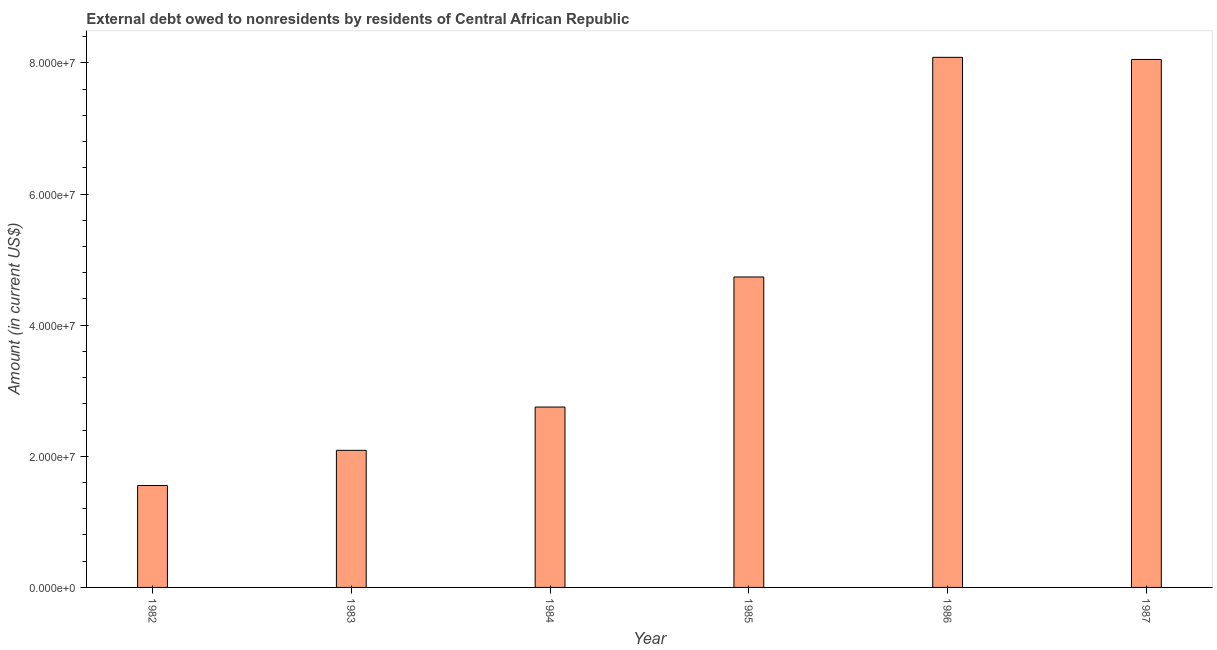Does the graph contain any zero values?
Keep it short and to the point. No. Does the graph contain grids?
Provide a short and direct response. No. What is the title of the graph?
Provide a succinct answer. External debt owed to nonresidents by residents of Central African Republic. What is the debt in 1983?
Your response must be concise. 2.09e+07. Across all years, what is the maximum debt?
Provide a succinct answer. 8.09e+07. Across all years, what is the minimum debt?
Make the answer very short. 1.55e+07. In which year was the debt maximum?
Your answer should be very brief. 1986. In which year was the debt minimum?
Give a very brief answer. 1982. What is the sum of the debt?
Your answer should be very brief. 2.73e+08. What is the difference between the debt in 1982 and 1987?
Make the answer very short. -6.50e+07. What is the average debt per year?
Provide a short and direct response. 4.55e+07. What is the median debt?
Provide a short and direct response. 3.74e+07. Do a majority of the years between 1986 and 1984 (inclusive) have debt greater than 76000000 US$?
Give a very brief answer. Yes. Is the difference between the debt in 1982 and 1987 greater than the difference between any two years?
Make the answer very short. No. What is the difference between the highest and the second highest debt?
Your response must be concise. 3.24e+05. What is the difference between the highest and the lowest debt?
Ensure brevity in your answer.  6.53e+07. In how many years, is the debt greater than the average debt taken over all years?
Your answer should be compact. 3. How many bars are there?
Your answer should be very brief. 6. What is the difference between two consecutive major ticks on the Y-axis?
Provide a short and direct response. 2.00e+07. What is the Amount (in current US$) in 1982?
Keep it short and to the point. 1.55e+07. What is the Amount (in current US$) of 1983?
Offer a very short reply. 2.09e+07. What is the Amount (in current US$) of 1984?
Ensure brevity in your answer.  2.75e+07. What is the Amount (in current US$) in 1985?
Provide a short and direct response. 4.74e+07. What is the Amount (in current US$) of 1986?
Keep it short and to the point. 8.09e+07. What is the Amount (in current US$) in 1987?
Ensure brevity in your answer.  8.05e+07. What is the difference between the Amount (in current US$) in 1982 and 1983?
Your response must be concise. -5.37e+06. What is the difference between the Amount (in current US$) in 1982 and 1984?
Keep it short and to the point. -1.20e+07. What is the difference between the Amount (in current US$) in 1982 and 1985?
Your response must be concise. -3.18e+07. What is the difference between the Amount (in current US$) in 1982 and 1986?
Ensure brevity in your answer.  -6.53e+07. What is the difference between the Amount (in current US$) in 1982 and 1987?
Your response must be concise. -6.50e+07. What is the difference between the Amount (in current US$) in 1983 and 1984?
Offer a terse response. -6.60e+06. What is the difference between the Amount (in current US$) in 1983 and 1985?
Your answer should be compact. -2.64e+07. What is the difference between the Amount (in current US$) in 1983 and 1986?
Offer a terse response. -5.99e+07. What is the difference between the Amount (in current US$) in 1983 and 1987?
Your answer should be very brief. -5.96e+07. What is the difference between the Amount (in current US$) in 1984 and 1985?
Make the answer very short. -1.98e+07. What is the difference between the Amount (in current US$) in 1984 and 1986?
Provide a short and direct response. -5.33e+07. What is the difference between the Amount (in current US$) in 1984 and 1987?
Make the answer very short. -5.30e+07. What is the difference between the Amount (in current US$) in 1985 and 1986?
Make the answer very short. -3.35e+07. What is the difference between the Amount (in current US$) in 1985 and 1987?
Offer a very short reply. -3.32e+07. What is the difference between the Amount (in current US$) in 1986 and 1987?
Ensure brevity in your answer.  3.24e+05. What is the ratio of the Amount (in current US$) in 1982 to that in 1983?
Give a very brief answer. 0.74. What is the ratio of the Amount (in current US$) in 1982 to that in 1984?
Give a very brief answer. 0.56. What is the ratio of the Amount (in current US$) in 1982 to that in 1985?
Give a very brief answer. 0.33. What is the ratio of the Amount (in current US$) in 1982 to that in 1986?
Your answer should be very brief. 0.19. What is the ratio of the Amount (in current US$) in 1982 to that in 1987?
Offer a terse response. 0.19. What is the ratio of the Amount (in current US$) in 1983 to that in 1984?
Ensure brevity in your answer.  0.76. What is the ratio of the Amount (in current US$) in 1983 to that in 1985?
Offer a very short reply. 0.44. What is the ratio of the Amount (in current US$) in 1983 to that in 1986?
Your answer should be very brief. 0.26. What is the ratio of the Amount (in current US$) in 1983 to that in 1987?
Make the answer very short. 0.26. What is the ratio of the Amount (in current US$) in 1984 to that in 1985?
Make the answer very short. 0.58. What is the ratio of the Amount (in current US$) in 1984 to that in 1986?
Provide a succinct answer. 0.34. What is the ratio of the Amount (in current US$) in 1984 to that in 1987?
Offer a very short reply. 0.34. What is the ratio of the Amount (in current US$) in 1985 to that in 1986?
Your response must be concise. 0.59. What is the ratio of the Amount (in current US$) in 1985 to that in 1987?
Provide a succinct answer. 0.59. 